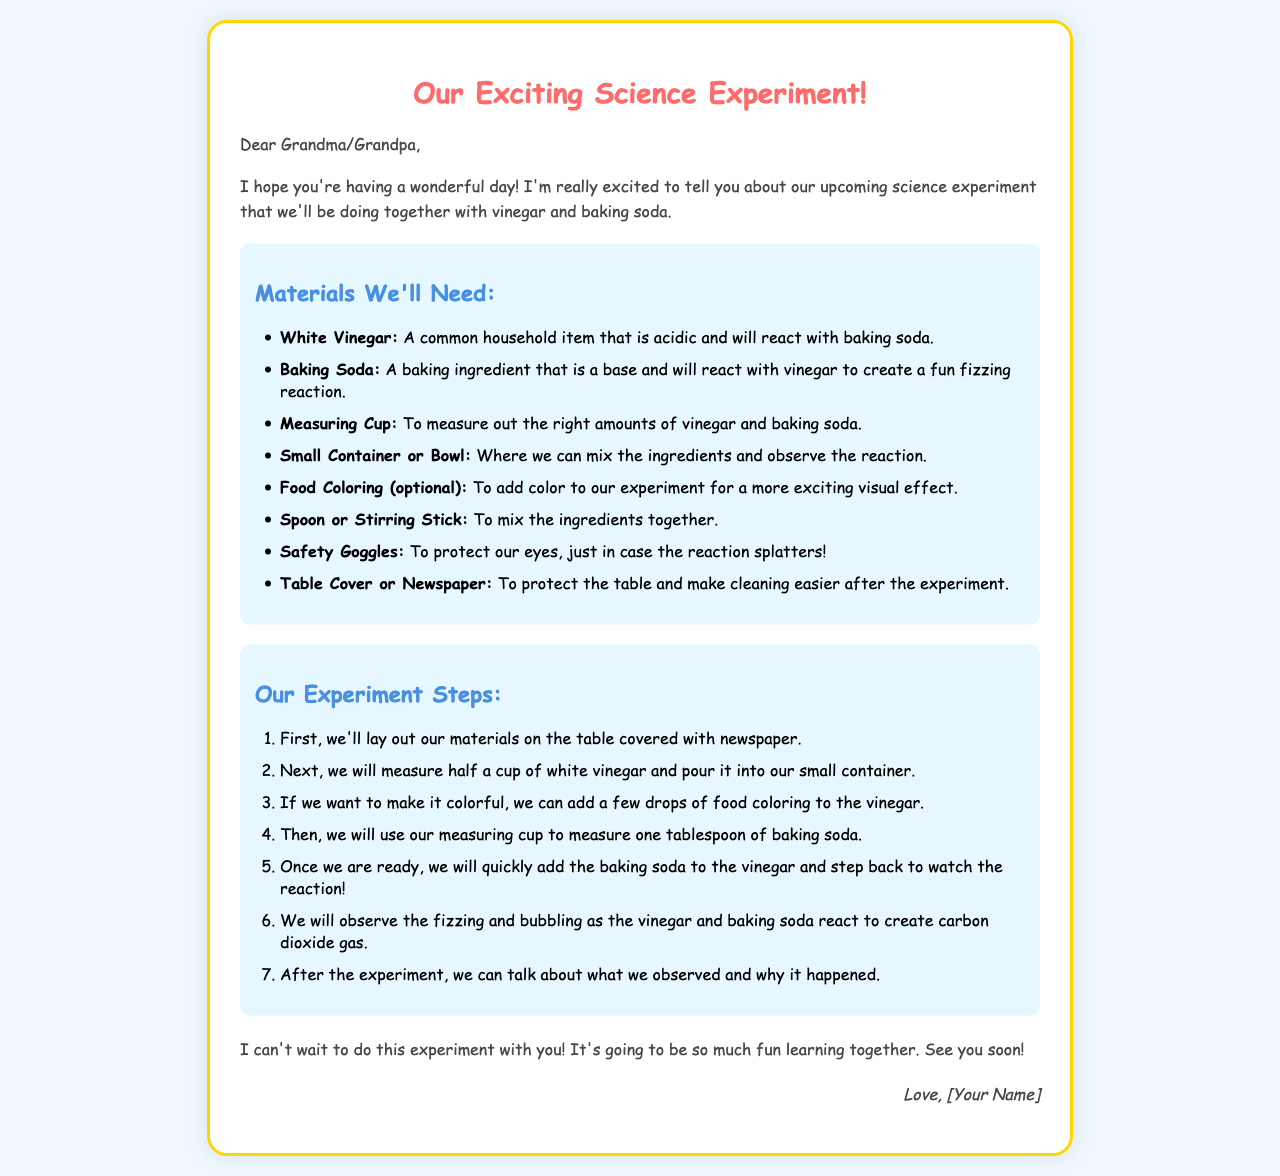What are the two main ingredients we'll use? The letter lists vinegar and baking soda as the main ingredients for the experiment.
Answer: vinegar and baking soda How many tablespoons of baking soda are needed? The steps specify that one tablespoon of baking soda will be used in the experiment.
Answer: one tablespoon What optional item can we add for color? The letter mentions food coloring as an optional item to make the experiment more visually exciting.
Answer: food coloring What protective gear should we wear for safety? The materials section advises wearing safety goggles to protect our eyes during the experiment.
Answer: safety goggles What will we observe when we mix the ingredients? The steps indicate that we will observe fizzing and bubbling as the reaction occurs.
Answer: fizzing and bubbling How will we prepare the table before starting the experiment? The first step involves laying out the materials on a table covered with newspaper.
Answer: newspaper What do we do after the experiment? The letter suggests talking about our observations and why the reaction happened after the experiment.
Answer: talk about observations Who is the letter addressed to? The letter starts with "Dear Grandma/Grandpa," indicating it is addressed to a grandparent.
Answer: Grandma/Grandpa 